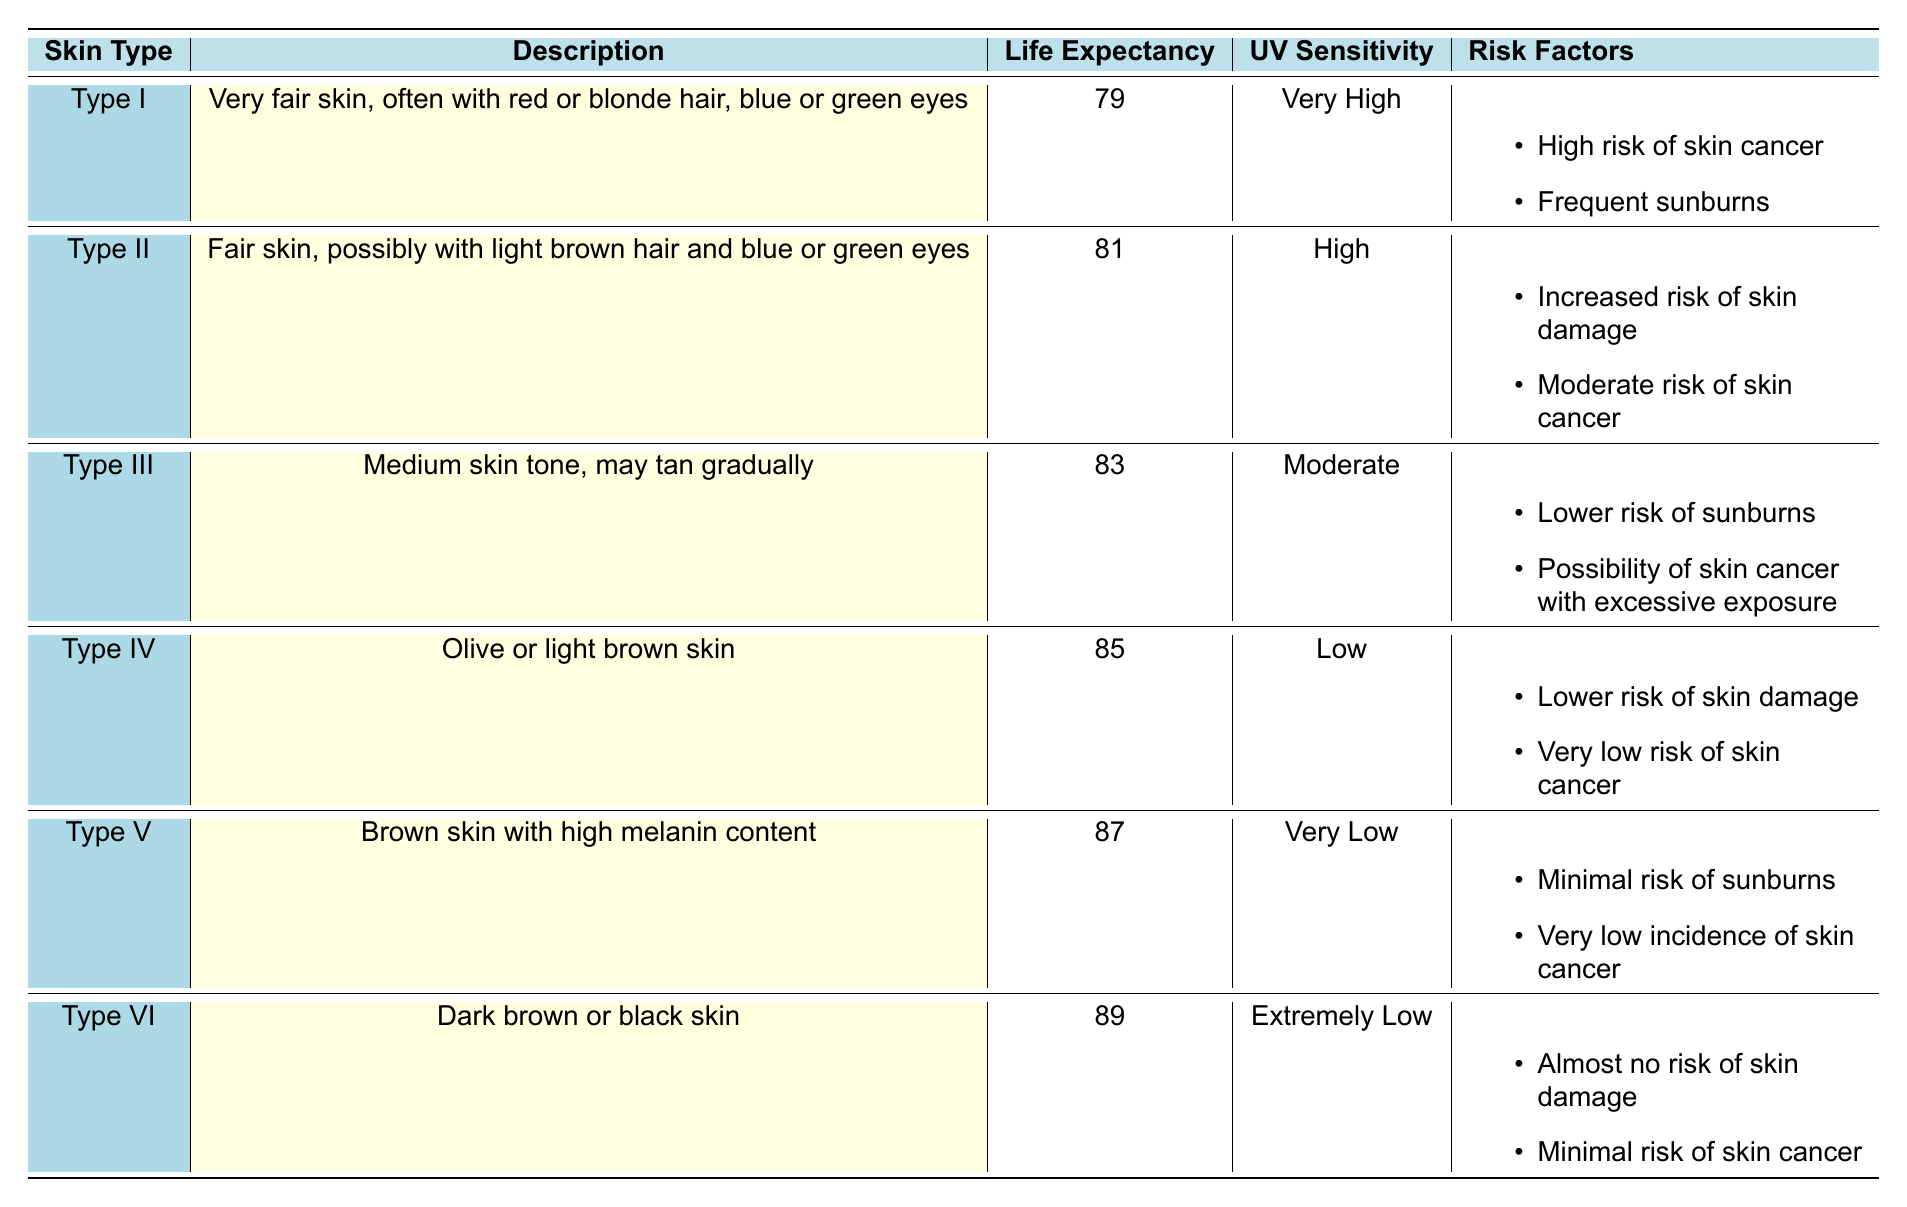What is the average life expectancy for skin type V? According to the table, skin type V has an average life expectancy of 87 years.
Answer: 87 Which skin type has the lowest UV sensitivity? Referring to the table, skin type VI has a UV sensitivity labeled as "Extremely Low," which is the lowest among the types listed.
Answer: Type VI What is the average life expectancy of skin types I and II combined? For skin types I and II, their life expectancies are 79 and 81 years respectively. Adding them together gives 79 + 81 = 160, then dividing by 2 for the average results in 160/2 = 80.
Answer: 80 Does skin type IV have a high risk of skin cancer? The risk factors for skin type IV state that it has a "Very low risk of skin cancer," which means the answer to the question is no.
Answer: No Which skin type has the highest average life expectancy and what is it? The table indicates that skin type VI has the highest average life expectancy of 89 years. Therefore, the skin type with the highest life expectancy is VI with a value of 89.
Answer: Type VI, 89 What is the difference in life expectancy between skin types III and V? The average life expectancy for skin type III is 83 years and for skin type V, it is 87 years. The difference is found by subtracting 83 from 87, which equals 4 years.
Answer: 4 Is it true that all skin types have at least a moderate risk of sunburns? By reviewing the risk factors in the table, skin types I and II indeed show higher risk categories, while skin type IV has a lower risk of skin damage, skin type V has minimal risk of sunburns, and skin type VI has almost no risk. Hence, it is false that all skin types have at least a moderate risk of sunburn.
Answer: No For which skin type is the risk of skin damage the lowest? In the table, skin type V shows "Minimal risk of sunburns," but skin type VI specifies "Almost no risk of skin damage," making skin type VI the one with the lowest risk in this context.
Answer: Type VI 